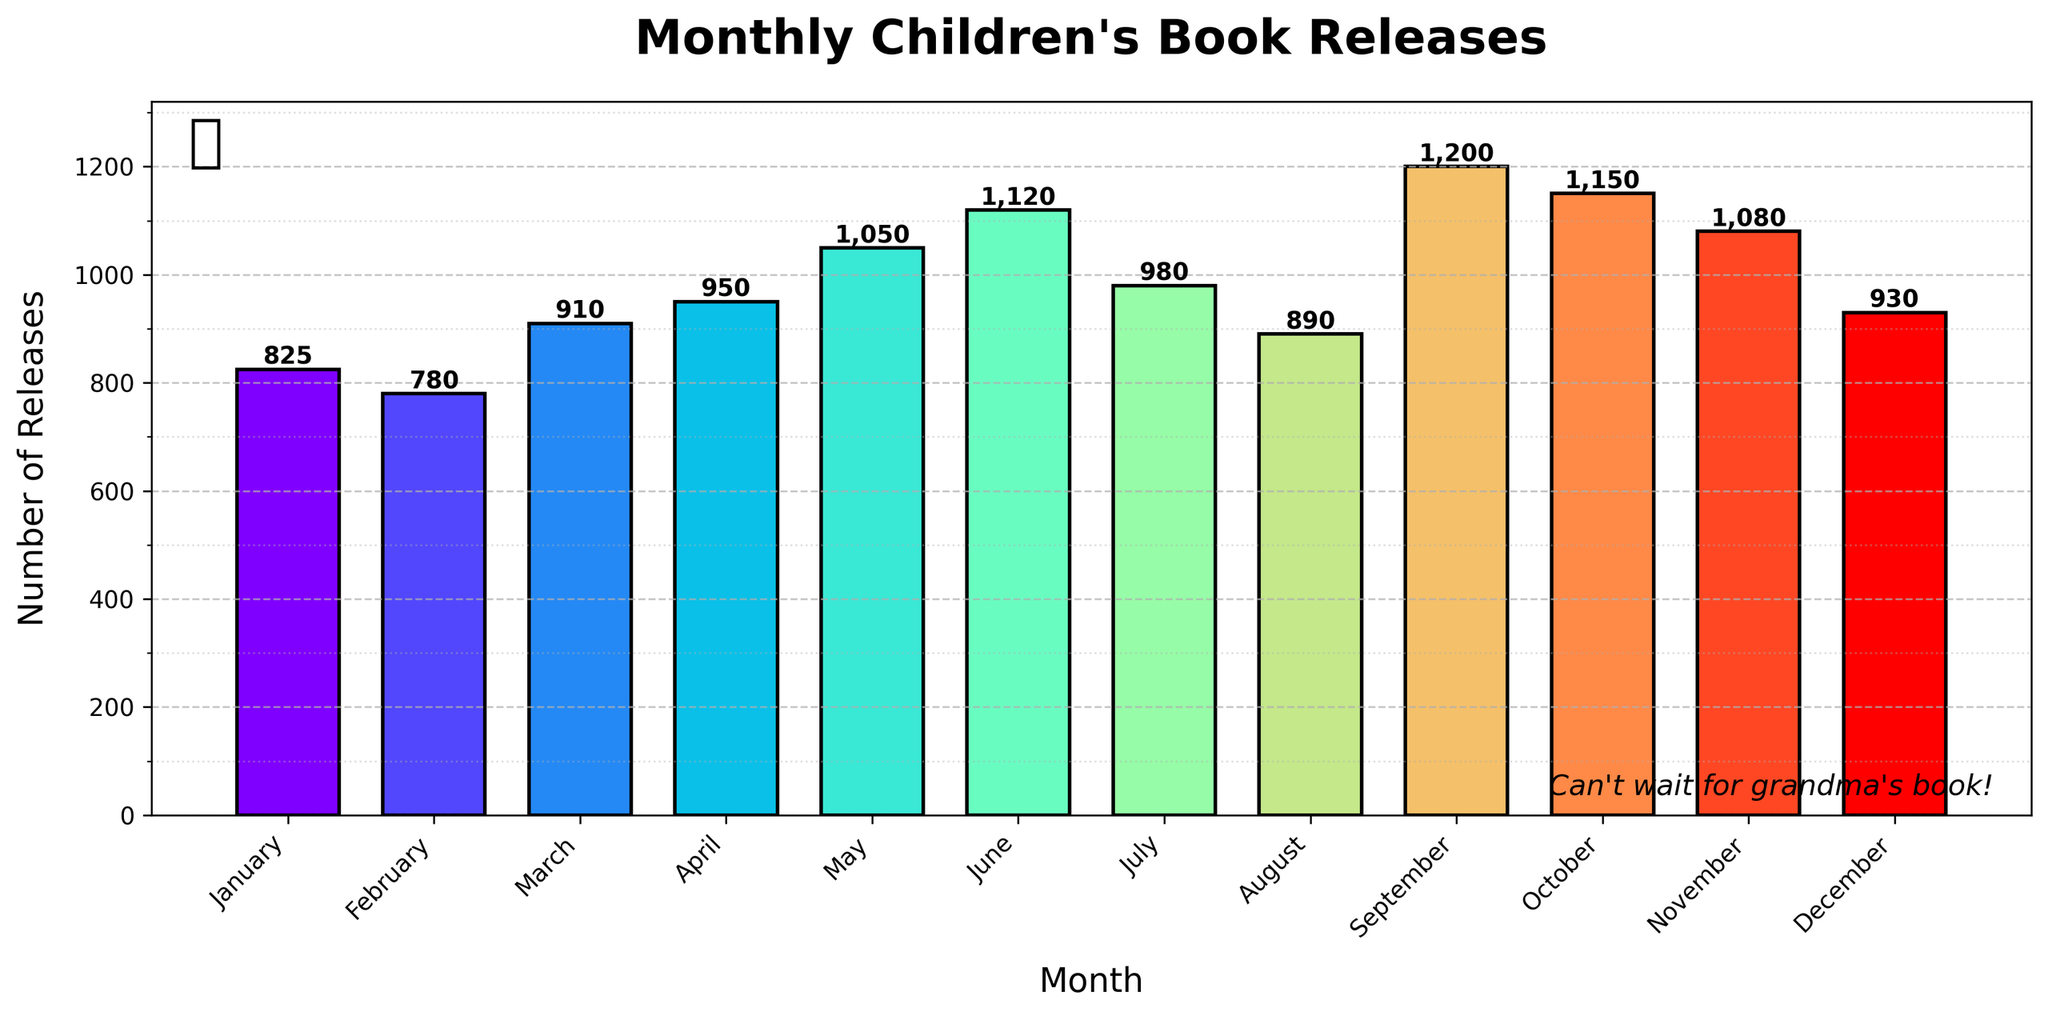How many new children's books were released in March? Refer to the height of the bar corresponding to March to find the value labeled above it. The number is given as 910.
Answer: 910 Which month had the highest number of new children's book releases? Identify the tallest bar in the figure, which corresponds to the month with the highest releases. The tallest bar is in September.
Answer: September Did more books get released in February compared to December? Compare the height of the bars for February and December. The February bar is shorter than the December bar, indicating fewer releases in February.
Answer: No How many more books were released in June compared to August? Find the value for June (1120) and August (890), then subtract August's releases from June's. 1120 - 890 = 230.
Answer: 230 What is the total number of new children's book releases from June to September? Sum the values from June (1120), July (980), August (890), and September (1200). Total = 1120 + 980 + 890 + 1200 = 4190.
Answer: 4190 Which month had the least number of new children's book releases? Identify the shortest bar in the figure, which corresponds to February with 780 releases.
Answer: February How do the new book releases in April compare to those in October? Refer to the height of the bars for April (950) and October (1150), noting that October's bar is taller, indicating more releases.
Answer: October has more What is the average number of new children's book releases per month for the entire year? Sum all the monthly values and divide by 12. (825 + 780 + 910 + 950 + 1050 + 1120 + 980 + 890 + 1200 + 1150 + 1080 + 930) / 12 ≈ 9875 / 12 ≈ 823.
Answer: ≈ 823 Compare the book releases in January and May. Which month had more and by how much? Check the values for January (825) and May (1050). May had more releases; subtract January's from May's. 1050 - 825 = 225.
Answer: May had 225 more What's the difference in releases between the month with the highest and the month with the lowest releases? Identify the highest (September with 1200) and lowest (February with 780) and subtract the lowest from the highest. 1200 - 780 = 420.
Answer: 420 